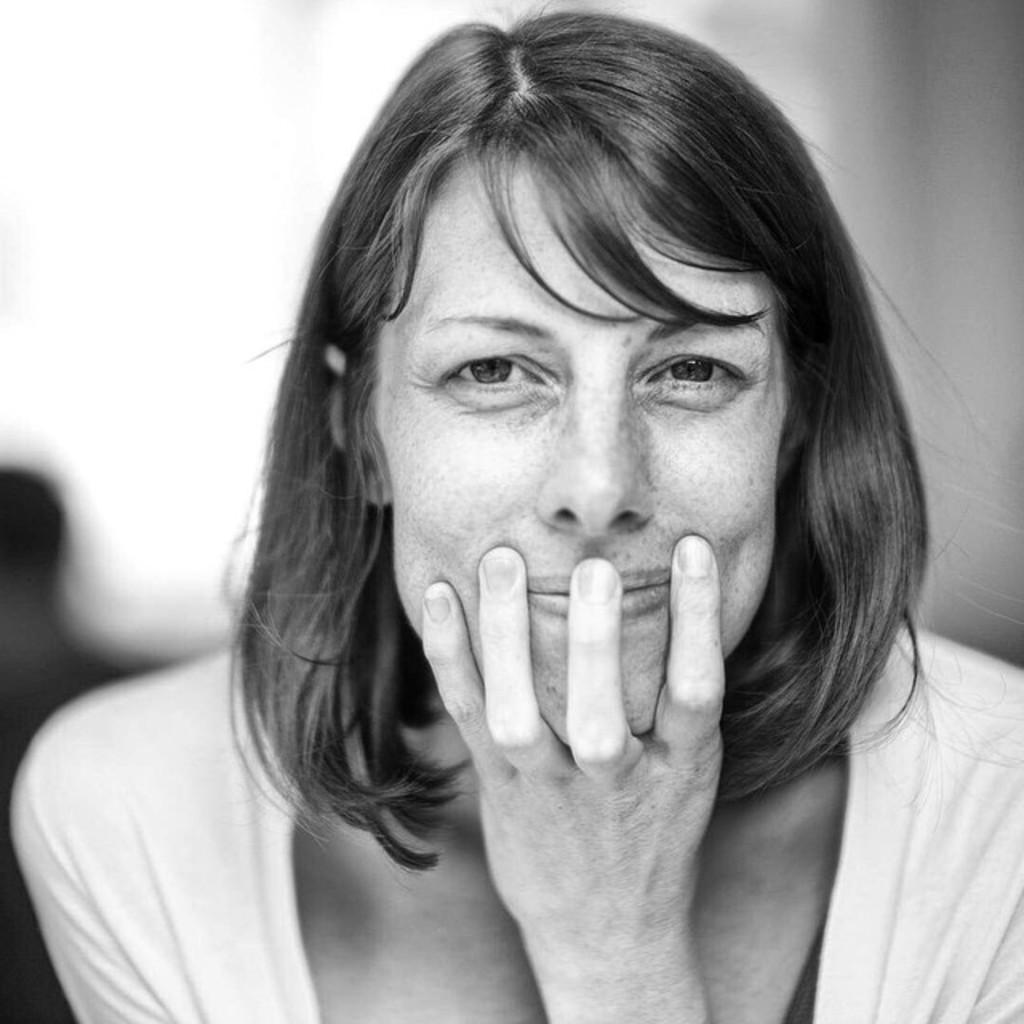How would you summarize this image in a sentence or two? This is the black and white picture of a woman. 